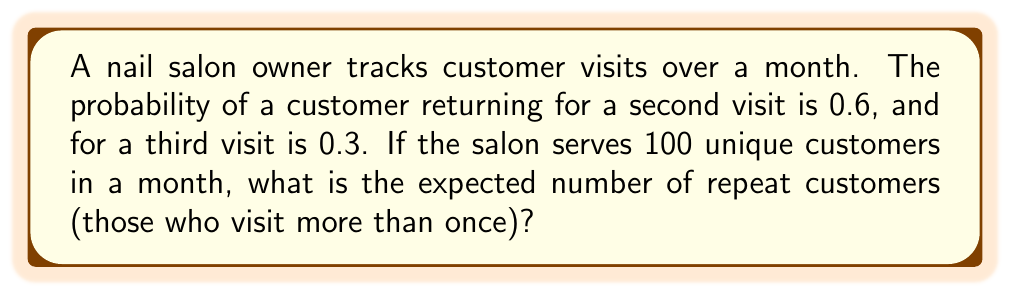Show me your answer to this math problem. Let's approach this step-by-step:

1) First, we need to understand what constitutes a repeat customer. It's someone who visits at least twice in the month.

2) We have two scenarios for repeat customers:
   - Those who visit twice
   - Those who visit three times

3) For customers visiting twice:
   - Probability = 0.6
   - Number of customers = 100 * 0.6 = 60

4) For customers visiting three times:
   - Probability = 0.3
   - Number of customers = 100 * 0.3 = 30

5) The total number of repeat customers is the sum of these two groups:

   $$E[\text{Repeat Customers}] = 60 + 30 = 90$$

6) To verify, we can use the formula for expected value:

   $$E[X] = \sum_{i=1}^{n} x_i \cdot p(x_i)$$

   Where $x_i$ is the number of repeat visits (1 or 2) and $p(x_i)$ is the probability.

   $$E[X] = 1 \cdot 0.6 + 2 \cdot 0.3 = 0.6 + 0.6 = 1.2$$

   This means, on average, each customer makes 1.2 repeat visits.

7) For 100 customers:

   $$100 \cdot 1.2 = 120$$ total repeat visits

8) But remember, we're counting customers, not visits. The 60 who visit twice and the 30 who visit thrice are the same 90 people.

Therefore, the expected number of repeat customers is 90.
Answer: 90 repeat customers 